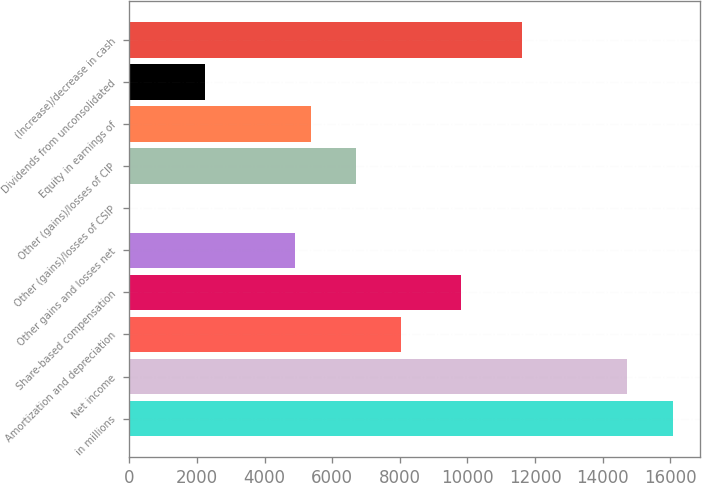Convert chart to OTSL. <chart><loc_0><loc_0><loc_500><loc_500><bar_chart><fcel>in millions<fcel>Net income<fcel>Amortization and depreciation<fcel>Share-based compensation<fcel>Other gains and losses net<fcel>Other (gains)/losses of CSIP<fcel>Other (gains)/losses of CIP<fcel>Equity in earnings of<fcel>Dividends from unconsolidated<fcel>(Increase)/decrease in cash<nl><fcel>16070.2<fcel>14731.2<fcel>8036.12<fcel>9821.48<fcel>4911.74<fcel>2<fcel>6697.1<fcel>5358.08<fcel>2233.7<fcel>11606.8<nl></chart> 